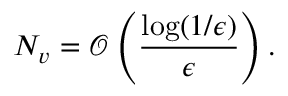<formula> <loc_0><loc_0><loc_500><loc_500>N _ { v } = \mathcal { O } \left ( \frac { \log ( 1 / \epsilon ) } { \epsilon } \right ) .</formula> 